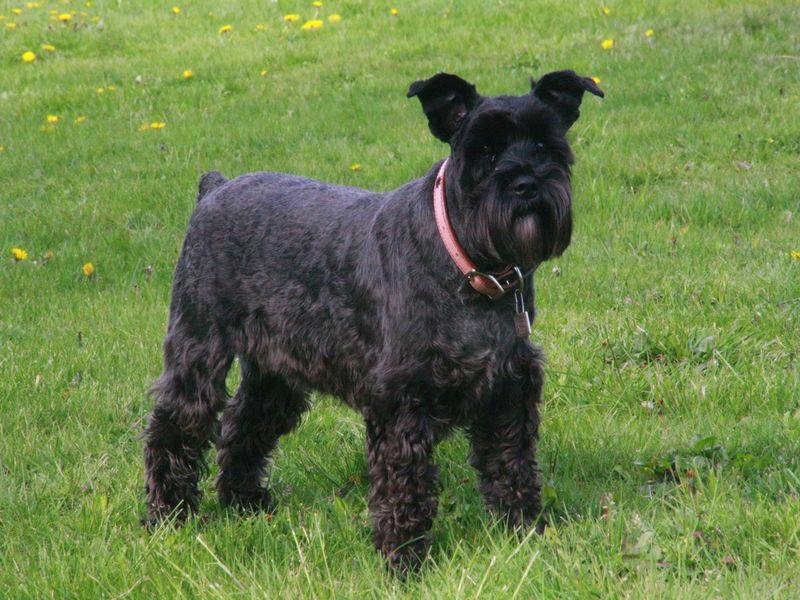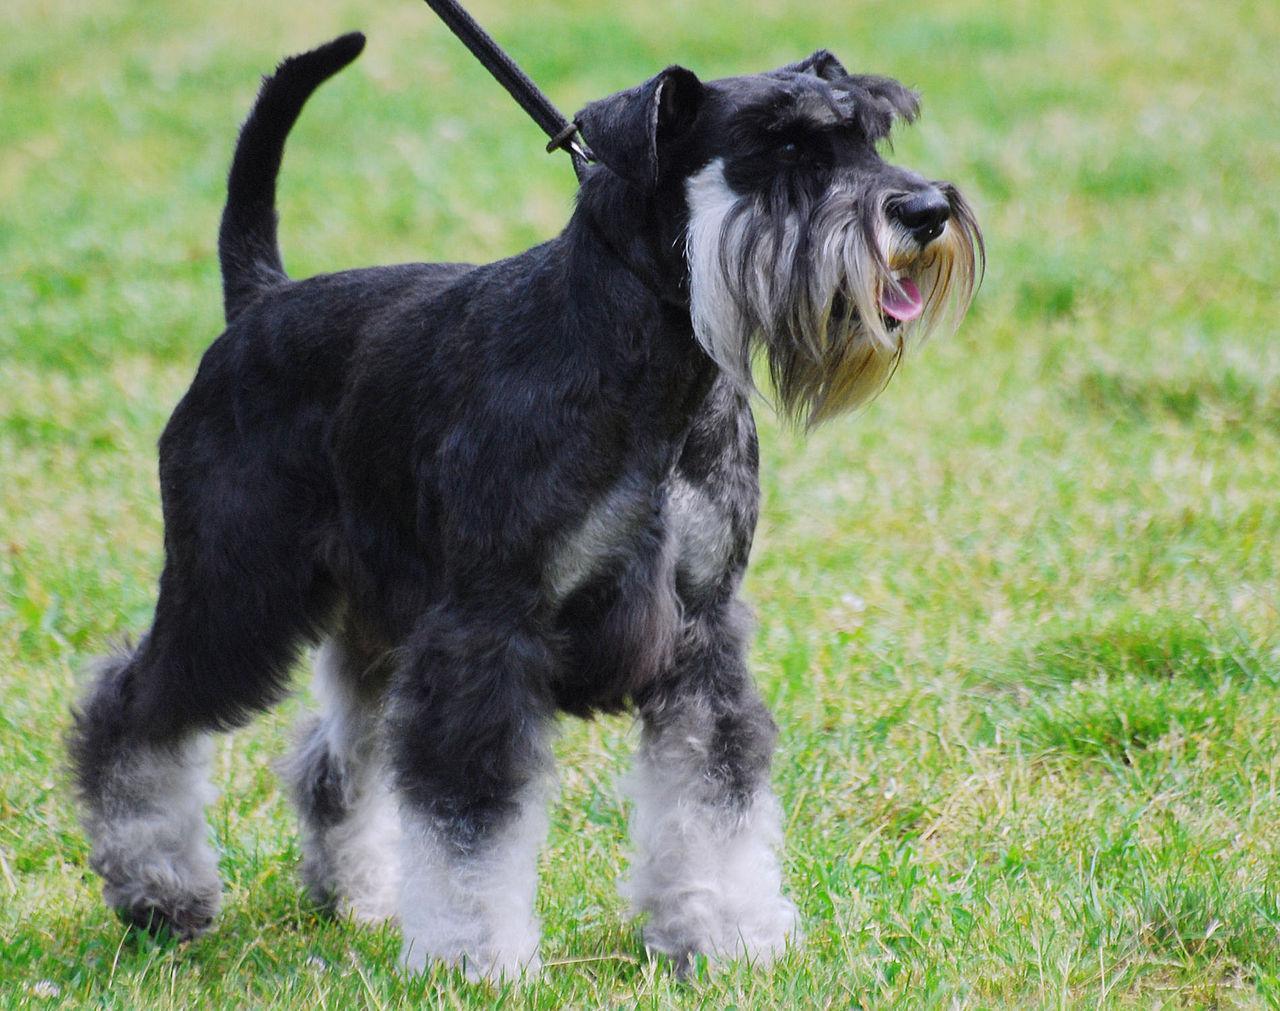The first image is the image on the left, the second image is the image on the right. For the images displayed, is the sentence "a dog is standing in the grass with a taught leash" factually correct? Answer yes or no. Yes. The first image is the image on the left, the second image is the image on the right. For the images shown, is this caption "One of the two dogs is NOT on a leash." true? Answer yes or no. Yes. 